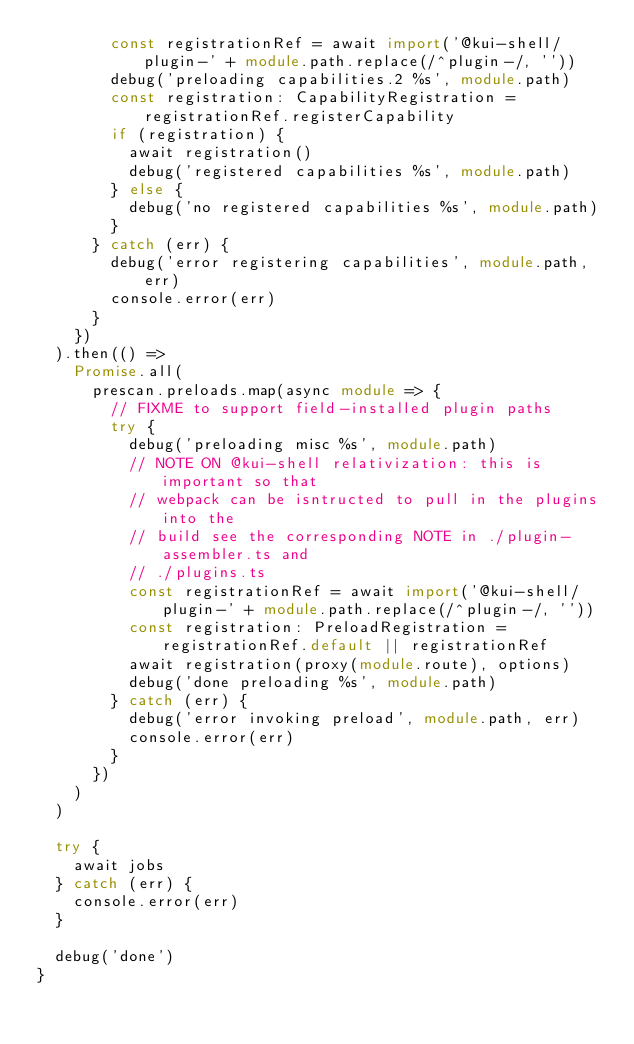<code> <loc_0><loc_0><loc_500><loc_500><_TypeScript_>        const registrationRef = await import('@kui-shell/plugin-' + module.path.replace(/^plugin-/, ''))
        debug('preloading capabilities.2 %s', module.path)
        const registration: CapabilityRegistration = registrationRef.registerCapability
        if (registration) {
          await registration()
          debug('registered capabilities %s', module.path)
        } else {
          debug('no registered capabilities %s', module.path)
        }
      } catch (err) {
        debug('error registering capabilities', module.path, err)
        console.error(err)
      }
    })
  ).then(() =>
    Promise.all(
      prescan.preloads.map(async module => {
        // FIXME to support field-installed plugin paths
        try {
          debug('preloading misc %s', module.path)
          // NOTE ON @kui-shell relativization: this is important so that
          // webpack can be isntructed to pull in the plugins into the
          // build see the corresponding NOTE in ./plugin-assembler.ts and
          // ./plugins.ts
          const registrationRef = await import('@kui-shell/plugin-' + module.path.replace(/^plugin-/, ''))
          const registration: PreloadRegistration = registrationRef.default || registrationRef
          await registration(proxy(module.route), options)
          debug('done preloading %s', module.path)
        } catch (err) {
          debug('error invoking preload', module.path, err)
          console.error(err)
        }
      })
    )
  )

  try {
    await jobs
  } catch (err) {
    console.error(err)
  }

  debug('done')
}
</code> 